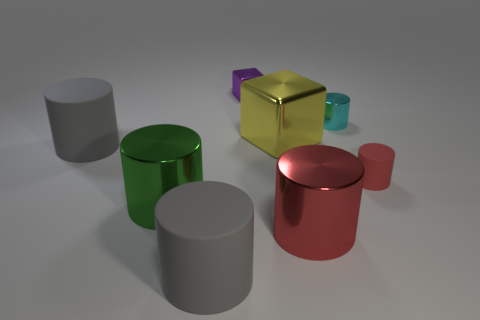Add 2 red rubber cylinders. How many objects exist? 10 Subtract all large green metallic cylinders. How many cylinders are left? 5 Subtract all purple cubes. How many red cylinders are left? 2 Subtract all green cylinders. How many cylinders are left? 5 Add 7 tiny objects. How many tiny objects exist? 10 Subtract 0 brown balls. How many objects are left? 8 Subtract all cylinders. How many objects are left? 2 Subtract all red cylinders. Subtract all cyan balls. How many cylinders are left? 4 Subtract all yellow cylinders. Subtract all purple cubes. How many objects are left? 7 Add 4 big green metallic cylinders. How many big green metallic cylinders are left? 5 